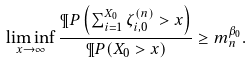Convert formula to latex. <formula><loc_0><loc_0><loc_500><loc_500>\liminf _ { x \to \infty } \frac { \P P \left ( \sum _ { i = 1 } ^ { X _ { 0 } } \zeta _ { i , 0 } ^ { ( n ) } > x \right ) } { \P P ( X _ { 0 } > x ) } \geq m _ { n } ^ { \beta _ { 0 } } .</formula> 